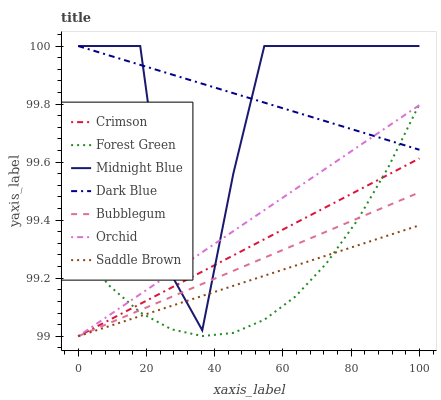Does Saddle Brown have the minimum area under the curve?
Answer yes or no. Yes. Does Dark Blue have the maximum area under the curve?
Answer yes or no. Yes. Does Bubblegum have the minimum area under the curve?
Answer yes or no. No. Does Bubblegum have the maximum area under the curve?
Answer yes or no. No. Is Crimson the smoothest?
Answer yes or no. Yes. Is Midnight Blue the roughest?
Answer yes or no. Yes. Is Bubblegum the smoothest?
Answer yes or no. No. Is Bubblegum the roughest?
Answer yes or no. No. Does Bubblegum have the lowest value?
Answer yes or no. Yes. Does Dark Blue have the lowest value?
Answer yes or no. No. Does Dark Blue have the highest value?
Answer yes or no. Yes. Does Bubblegum have the highest value?
Answer yes or no. No. Is Bubblegum less than Dark Blue?
Answer yes or no. Yes. Is Midnight Blue greater than Forest Green?
Answer yes or no. Yes. Does Crimson intersect Forest Green?
Answer yes or no. Yes. Is Crimson less than Forest Green?
Answer yes or no. No. Is Crimson greater than Forest Green?
Answer yes or no. No. Does Bubblegum intersect Dark Blue?
Answer yes or no. No. 